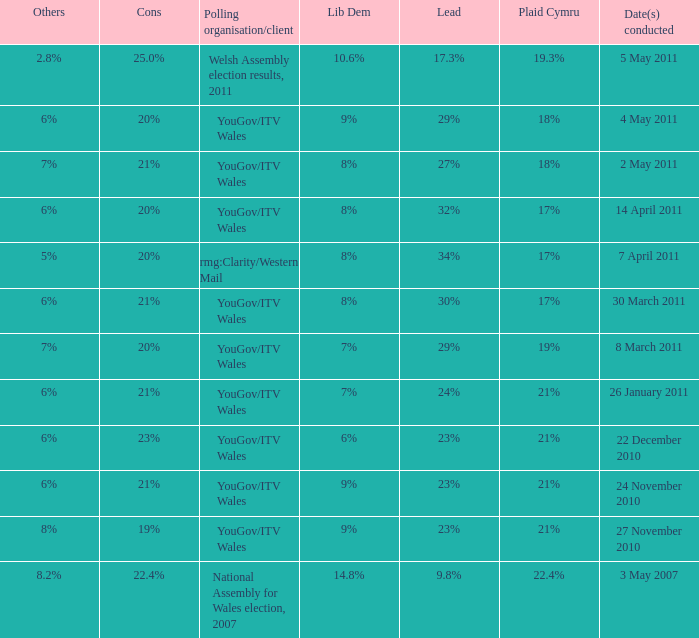Tell me the dates conducted for plaid cymru of 19% 8 March 2011. 